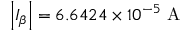<formula> <loc_0><loc_0><loc_500><loc_500>\left | I _ { \beta } \right | = 6 . 6 4 2 4 \times 1 0 ^ { - 5 } A</formula> 